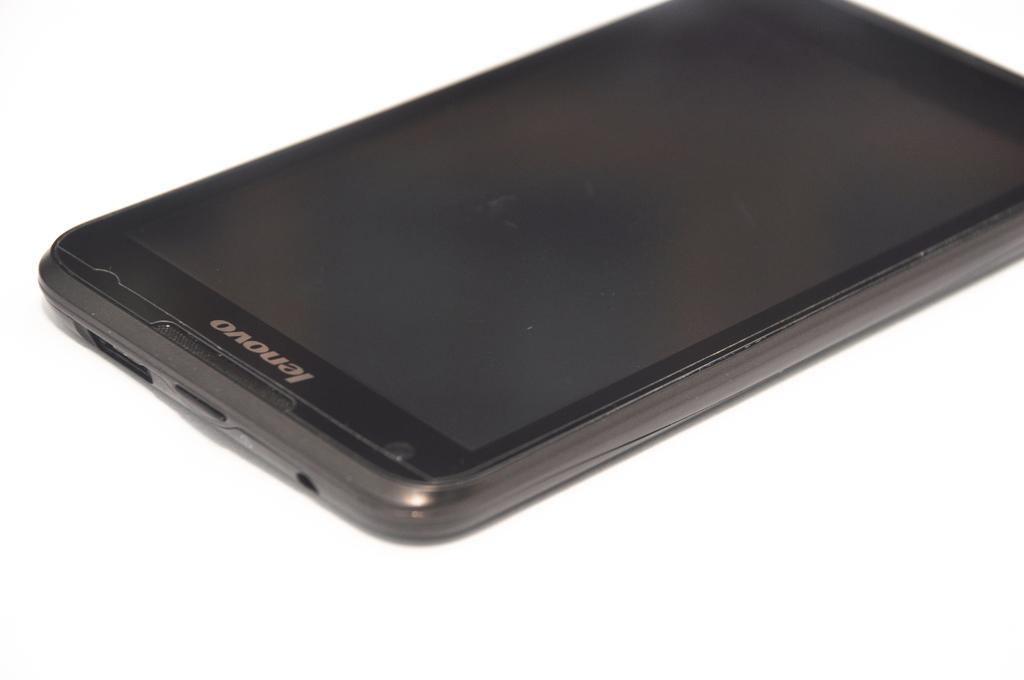<image>
Present a compact description of the photo's key features. An unpowered Lenovo branded cell phone is laying on a white background. 